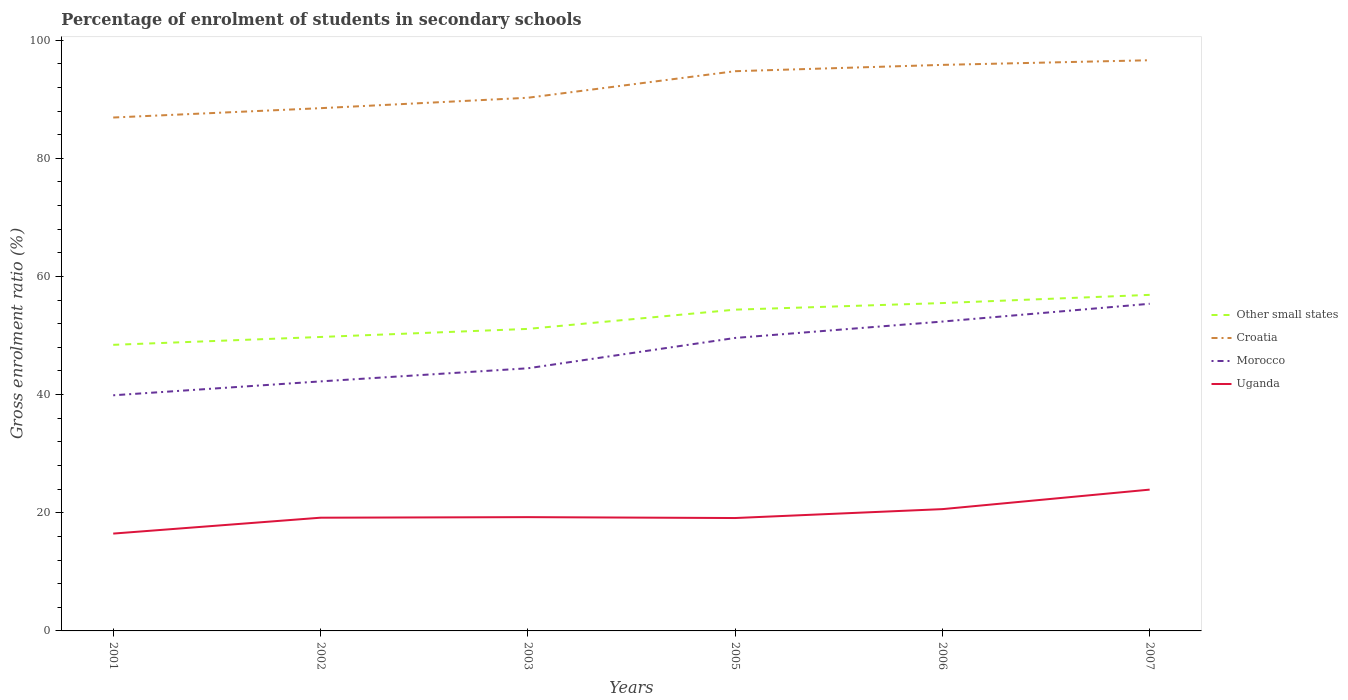How many different coloured lines are there?
Offer a terse response. 4. Does the line corresponding to Croatia intersect with the line corresponding to Uganda?
Offer a terse response. No. Is the number of lines equal to the number of legend labels?
Offer a terse response. Yes. Across all years, what is the maximum percentage of students enrolled in secondary schools in Croatia?
Make the answer very short. 86.91. In which year was the percentage of students enrolled in secondary schools in Uganda maximum?
Provide a short and direct response. 2001. What is the total percentage of students enrolled in secondary schools in Morocco in the graph?
Your answer should be compact. -9.71. What is the difference between the highest and the second highest percentage of students enrolled in secondary schools in Croatia?
Make the answer very short. 9.69. How many years are there in the graph?
Make the answer very short. 6. Does the graph contain any zero values?
Offer a terse response. No. Does the graph contain grids?
Your answer should be compact. No. Where does the legend appear in the graph?
Ensure brevity in your answer.  Center right. How many legend labels are there?
Provide a succinct answer. 4. How are the legend labels stacked?
Your answer should be compact. Vertical. What is the title of the graph?
Your answer should be very brief. Percentage of enrolment of students in secondary schools. Does "Guyana" appear as one of the legend labels in the graph?
Offer a terse response. No. What is the label or title of the X-axis?
Offer a very short reply. Years. What is the Gross enrolment ratio (%) in Other small states in 2001?
Offer a very short reply. 48.43. What is the Gross enrolment ratio (%) of Croatia in 2001?
Your response must be concise. 86.91. What is the Gross enrolment ratio (%) of Morocco in 2001?
Your answer should be compact. 39.89. What is the Gross enrolment ratio (%) in Uganda in 2001?
Make the answer very short. 16.48. What is the Gross enrolment ratio (%) of Other small states in 2002?
Make the answer very short. 49.76. What is the Gross enrolment ratio (%) in Croatia in 2002?
Your response must be concise. 88.49. What is the Gross enrolment ratio (%) in Morocco in 2002?
Provide a succinct answer. 42.24. What is the Gross enrolment ratio (%) of Uganda in 2002?
Offer a terse response. 19.16. What is the Gross enrolment ratio (%) of Other small states in 2003?
Provide a short and direct response. 51.12. What is the Gross enrolment ratio (%) of Croatia in 2003?
Ensure brevity in your answer.  90.25. What is the Gross enrolment ratio (%) in Morocco in 2003?
Your answer should be compact. 44.46. What is the Gross enrolment ratio (%) of Uganda in 2003?
Provide a succinct answer. 19.26. What is the Gross enrolment ratio (%) in Other small states in 2005?
Keep it short and to the point. 54.38. What is the Gross enrolment ratio (%) in Croatia in 2005?
Make the answer very short. 94.75. What is the Gross enrolment ratio (%) in Morocco in 2005?
Ensure brevity in your answer.  49.59. What is the Gross enrolment ratio (%) in Uganda in 2005?
Give a very brief answer. 19.11. What is the Gross enrolment ratio (%) in Other small states in 2006?
Your answer should be compact. 55.5. What is the Gross enrolment ratio (%) in Croatia in 2006?
Give a very brief answer. 95.81. What is the Gross enrolment ratio (%) in Morocco in 2006?
Provide a short and direct response. 52.37. What is the Gross enrolment ratio (%) in Uganda in 2006?
Give a very brief answer. 20.62. What is the Gross enrolment ratio (%) in Other small states in 2007?
Provide a short and direct response. 56.89. What is the Gross enrolment ratio (%) of Croatia in 2007?
Give a very brief answer. 96.6. What is the Gross enrolment ratio (%) of Morocco in 2007?
Your response must be concise. 55.38. What is the Gross enrolment ratio (%) in Uganda in 2007?
Ensure brevity in your answer.  23.92. Across all years, what is the maximum Gross enrolment ratio (%) of Other small states?
Your answer should be compact. 56.89. Across all years, what is the maximum Gross enrolment ratio (%) of Croatia?
Ensure brevity in your answer.  96.6. Across all years, what is the maximum Gross enrolment ratio (%) of Morocco?
Your answer should be very brief. 55.38. Across all years, what is the maximum Gross enrolment ratio (%) of Uganda?
Your response must be concise. 23.92. Across all years, what is the minimum Gross enrolment ratio (%) of Other small states?
Provide a short and direct response. 48.43. Across all years, what is the minimum Gross enrolment ratio (%) of Croatia?
Your answer should be compact. 86.91. Across all years, what is the minimum Gross enrolment ratio (%) in Morocco?
Give a very brief answer. 39.89. Across all years, what is the minimum Gross enrolment ratio (%) in Uganda?
Offer a terse response. 16.48. What is the total Gross enrolment ratio (%) in Other small states in the graph?
Offer a very short reply. 316.07. What is the total Gross enrolment ratio (%) of Croatia in the graph?
Offer a very short reply. 552.8. What is the total Gross enrolment ratio (%) in Morocco in the graph?
Offer a very short reply. 283.91. What is the total Gross enrolment ratio (%) in Uganda in the graph?
Make the answer very short. 118.54. What is the difference between the Gross enrolment ratio (%) of Other small states in 2001 and that in 2002?
Your answer should be very brief. -1.33. What is the difference between the Gross enrolment ratio (%) of Croatia in 2001 and that in 2002?
Provide a short and direct response. -1.58. What is the difference between the Gross enrolment ratio (%) of Morocco in 2001 and that in 2002?
Make the answer very short. -2.35. What is the difference between the Gross enrolment ratio (%) of Uganda in 2001 and that in 2002?
Keep it short and to the point. -2.69. What is the difference between the Gross enrolment ratio (%) in Other small states in 2001 and that in 2003?
Give a very brief answer. -2.7. What is the difference between the Gross enrolment ratio (%) in Croatia in 2001 and that in 2003?
Provide a succinct answer. -3.34. What is the difference between the Gross enrolment ratio (%) in Morocco in 2001 and that in 2003?
Your answer should be compact. -4.57. What is the difference between the Gross enrolment ratio (%) in Uganda in 2001 and that in 2003?
Provide a short and direct response. -2.78. What is the difference between the Gross enrolment ratio (%) in Other small states in 2001 and that in 2005?
Make the answer very short. -5.95. What is the difference between the Gross enrolment ratio (%) of Croatia in 2001 and that in 2005?
Ensure brevity in your answer.  -7.84. What is the difference between the Gross enrolment ratio (%) of Morocco in 2001 and that in 2005?
Provide a succinct answer. -9.71. What is the difference between the Gross enrolment ratio (%) of Uganda in 2001 and that in 2005?
Keep it short and to the point. -2.63. What is the difference between the Gross enrolment ratio (%) in Other small states in 2001 and that in 2006?
Offer a very short reply. -7.07. What is the difference between the Gross enrolment ratio (%) of Croatia in 2001 and that in 2006?
Your answer should be very brief. -8.91. What is the difference between the Gross enrolment ratio (%) in Morocco in 2001 and that in 2006?
Ensure brevity in your answer.  -12.48. What is the difference between the Gross enrolment ratio (%) of Uganda in 2001 and that in 2006?
Provide a short and direct response. -4.14. What is the difference between the Gross enrolment ratio (%) of Other small states in 2001 and that in 2007?
Make the answer very short. -8.46. What is the difference between the Gross enrolment ratio (%) of Croatia in 2001 and that in 2007?
Offer a very short reply. -9.69. What is the difference between the Gross enrolment ratio (%) in Morocco in 2001 and that in 2007?
Provide a succinct answer. -15.49. What is the difference between the Gross enrolment ratio (%) in Uganda in 2001 and that in 2007?
Your answer should be compact. -7.44. What is the difference between the Gross enrolment ratio (%) in Other small states in 2002 and that in 2003?
Your answer should be very brief. -1.37. What is the difference between the Gross enrolment ratio (%) of Croatia in 2002 and that in 2003?
Your answer should be very brief. -1.76. What is the difference between the Gross enrolment ratio (%) in Morocco in 2002 and that in 2003?
Keep it short and to the point. -2.22. What is the difference between the Gross enrolment ratio (%) in Uganda in 2002 and that in 2003?
Offer a very short reply. -0.09. What is the difference between the Gross enrolment ratio (%) of Other small states in 2002 and that in 2005?
Keep it short and to the point. -4.62. What is the difference between the Gross enrolment ratio (%) in Croatia in 2002 and that in 2005?
Offer a very short reply. -6.26. What is the difference between the Gross enrolment ratio (%) in Morocco in 2002 and that in 2005?
Provide a succinct answer. -7.35. What is the difference between the Gross enrolment ratio (%) in Uganda in 2002 and that in 2005?
Make the answer very short. 0.06. What is the difference between the Gross enrolment ratio (%) in Other small states in 2002 and that in 2006?
Ensure brevity in your answer.  -5.74. What is the difference between the Gross enrolment ratio (%) of Croatia in 2002 and that in 2006?
Keep it short and to the point. -7.33. What is the difference between the Gross enrolment ratio (%) in Morocco in 2002 and that in 2006?
Your answer should be very brief. -10.13. What is the difference between the Gross enrolment ratio (%) of Uganda in 2002 and that in 2006?
Make the answer very short. -1.45. What is the difference between the Gross enrolment ratio (%) of Other small states in 2002 and that in 2007?
Provide a succinct answer. -7.13. What is the difference between the Gross enrolment ratio (%) in Croatia in 2002 and that in 2007?
Provide a short and direct response. -8.11. What is the difference between the Gross enrolment ratio (%) in Morocco in 2002 and that in 2007?
Your answer should be compact. -13.14. What is the difference between the Gross enrolment ratio (%) in Uganda in 2002 and that in 2007?
Offer a very short reply. -4.75. What is the difference between the Gross enrolment ratio (%) in Other small states in 2003 and that in 2005?
Your answer should be compact. -3.26. What is the difference between the Gross enrolment ratio (%) of Croatia in 2003 and that in 2005?
Your answer should be very brief. -4.5. What is the difference between the Gross enrolment ratio (%) in Morocco in 2003 and that in 2005?
Provide a succinct answer. -5.13. What is the difference between the Gross enrolment ratio (%) of Uganda in 2003 and that in 2005?
Make the answer very short. 0.15. What is the difference between the Gross enrolment ratio (%) in Other small states in 2003 and that in 2006?
Your answer should be very brief. -4.38. What is the difference between the Gross enrolment ratio (%) in Croatia in 2003 and that in 2006?
Offer a terse response. -5.56. What is the difference between the Gross enrolment ratio (%) in Morocco in 2003 and that in 2006?
Offer a terse response. -7.91. What is the difference between the Gross enrolment ratio (%) in Uganda in 2003 and that in 2006?
Offer a very short reply. -1.36. What is the difference between the Gross enrolment ratio (%) of Other small states in 2003 and that in 2007?
Give a very brief answer. -5.76. What is the difference between the Gross enrolment ratio (%) of Croatia in 2003 and that in 2007?
Offer a very short reply. -6.35. What is the difference between the Gross enrolment ratio (%) in Morocco in 2003 and that in 2007?
Provide a short and direct response. -10.92. What is the difference between the Gross enrolment ratio (%) in Uganda in 2003 and that in 2007?
Make the answer very short. -4.66. What is the difference between the Gross enrolment ratio (%) in Other small states in 2005 and that in 2006?
Offer a very short reply. -1.12. What is the difference between the Gross enrolment ratio (%) in Croatia in 2005 and that in 2006?
Make the answer very short. -1.07. What is the difference between the Gross enrolment ratio (%) in Morocco in 2005 and that in 2006?
Provide a short and direct response. -2.77. What is the difference between the Gross enrolment ratio (%) of Uganda in 2005 and that in 2006?
Your answer should be compact. -1.51. What is the difference between the Gross enrolment ratio (%) of Other small states in 2005 and that in 2007?
Provide a succinct answer. -2.51. What is the difference between the Gross enrolment ratio (%) of Croatia in 2005 and that in 2007?
Offer a very short reply. -1.85. What is the difference between the Gross enrolment ratio (%) in Morocco in 2005 and that in 2007?
Give a very brief answer. -5.78. What is the difference between the Gross enrolment ratio (%) in Uganda in 2005 and that in 2007?
Keep it short and to the point. -4.81. What is the difference between the Gross enrolment ratio (%) of Other small states in 2006 and that in 2007?
Offer a terse response. -1.39. What is the difference between the Gross enrolment ratio (%) of Croatia in 2006 and that in 2007?
Offer a very short reply. -0.79. What is the difference between the Gross enrolment ratio (%) in Morocco in 2006 and that in 2007?
Make the answer very short. -3.01. What is the difference between the Gross enrolment ratio (%) in Uganda in 2006 and that in 2007?
Offer a very short reply. -3.3. What is the difference between the Gross enrolment ratio (%) in Other small states in 2001 and the Gross enrolment ratio (%) in Croatia in 2002?
Your answer should be very brief. -40.06. What is the difference between the Gross enrolment ratio (%) in Other small states in 2001 and the Gross enrolment ratio (%) in Morocco in 2002?
Keep it short and to the point. 6.19. What is the difference between the Gross enrolment ratio (%) in Other small states in 2001 and the Gross enrolment ratio (%) in Uganda in 2002?
Offer a very short reply. 29.26. What is the difference between the Gross enrolment ratio (%) of Croatia in 2001 and the Gross enrolment ratio (%) of Morocco in 2002?
Keep it short and to the point. 44.67. What is the difference between the Gross enrolment ratio (%) in Croatia in 2001 and the Gross enrolment ratio (%) in Uganda in 2002?
Keep it short and to the point. 67.74. What is the difference between the Gross enrolment ratio (%) of Morocco in 2001 and the Gross enrolment ratio (%) of Uganda in 2002?
Offer a terse response. 20.72. What is the difference between the Gross enrolment ratio (%) of Other small states in 2001 and the Gross enrolment ratio (%) of Croatia in 2003?
Give a very brief answer. -41.82. What is the difference between the Gross enrolment ratio (%) of Other small states in 2001 and the Gross enrolment ratio (%) of Morocco in 2003?
Ensure brevity in your answer.  3.97. What is the difference between the Gross enrolment ratio (%) of Other small states in 2001 and the Gross enrolment ratio (%) of Uganda in 2003?
Ensure brevity in your answer.  29.17. What is the difference between the Gross enrolment ratio (%) of Croatia in 2001 and the Gross enrolment ratio (%) of Morocco in 2003?
Your response must be concise. 42.45. What is the difference between the Gross enrolment ratio (%) in Croatia in 2001 and the Gross enrolment ratio (%) in Uganda in 2003?
Offer a terse response. 67.65. What is the difference between the Gross enrolment ratio (%) in Morocco in 2001 and the Gross enrolment ratio (%) in Uganda in 2003?
Your response must be concise. 20.63. What is the difference between the Gross enrolment ratio (%) in Other small states in 2001 and the Gross enrolment ratio (%) in Croatia in 2005?
Make the answer very short. -46.32. What is the difference between the Gross enrolment ratio (%) in Other small states in 2001 and the Gross enrolment ratio (%) in Morocco in 2005?
Offer a terse response. -1.16. What is the difference between the Gross enrolment ratio (%) of Other small states in 2001 and the Gross enrolment ratio (%) of Uganda in 2005?
Your answer should be compact. 29.32. What is the difference between the Gross enrolment ratio (%) in Croatia in 2001 and the Gross enrolment ratio (%) in Morocco in 2005?
Keep it short and to the point. 37.31. What is the difference between the Gross enrolment ratio (%) of Croatia in 2001 and the Gross enrolment ratio (%) of Uganda in 2005?
Offer a terse response. 67.8. What is the difference between the Gross enrolment ratio (%) of Morocco in 2001 and the Gross enrolment ratio (%) of Uganda in 2005?
Your answer should be compact. 20.78. What is the difference between the Gross enrolment ratio (%) in Other small states in 2001 and the Gross enrolment ratio (%) in Croatia in 2006?
Ensure brevity in your answer.  -47.39. What is the difference between the Gross enrolment ratio (%) of Other small states in 2001 and the Gross enrolment ratio (%) of Morocco in 2006?
Offer a terse response. -3.94. What is the difference between the Gross enrolment ratio (%) in Other small states in 2001 and the Gross enrolment ratio (%) in Uganda in 2006?
Make the answer very short. 27.81. What is the difference between the Gross enrolment ratio (%) in Croatia in 2001 and the Gross enrolment ratio (%) in Morocco in 2006?
Make the answer very short. 34.54. What is the difference between the Gross enrolment ratio (%) in Croatia in 2001 and the Gross enrolment ratio (%) in Uganda in 2006?
Ensure brevity in your answer.  66.29. What is the difference between the Gross enrolment ratio (%) of Morocco in 2001 and the Gross enrolment ratio (%) of Uganda in 2006?
Offer a terse response. 19.27. What is the difference between the Gross enrolment ratio (%) of Other small states in 2001 and the Gross enrolment ratio (%) of Croatia in 2007?
Offer a terse response. -48.17. What is the difference between the Gross enrolment ratio (%) in Other small states in 2001 and the Gross enrolment ratio (%) in Morocco in 2007?
Make the answer very short. -6.95. What is the difference between the Gross enrolment ratio (%) in Other small states in 2001 and the Gross enrolment ratio (%) in Uganda in 2007?
Ensure brevity in your answer.  24.51. What is the difference between the Gross enrolment ratio (%) in Croatia in 2001 and the Gross enrolment ratio (%) in Morocco in 2007?
Make the answer very short. 31.53. What is the difference between the Gross enrolment ratio (%) of Croatia in 2001 and the Gross enrolment ratio (%) of Uganda in 2007?
Give a very brief answer. 62.99. What is the difference between the Gross enrolment ratio (%) of Morocco in 2001 and the Gross enrolment ratio (%) of Uganda in 2007?
Offer a terse response. 15.97. What is the difference between the Gross enrolment ratio (%) in Other small states in 2002 and the Gross enrolment ratio (%) in Croatia in 2003?
Ensure brevity in your answer.  -40.49. What is the difference between the Gross enrolment ratio (%) in Other small states in 2002 and the Gross enrolment ratio (%) in Morocco in 2003?
Your response must be concise. 5.3. What is the difference between the Gross enrolment ratio (%) in Other small states in 2002 and the Gross enrolment ratio (%) in Uganda in 2003?
Ensure brevity in your answer.  30.5. What is the difference between the Gross enrolment ratio (%) in Croatia in 2002 and the Gross enrolment ratio (%) in Morocco in 2003?
Your answer should be compact. 44.03. What is the difference between the Gross enrolment ratio (%) in Croatia in 2002 and the Gross enrolment ratio (%) in Uganda in 2003?
Offer a very short reply. 69.23. What is the difference between the Gross enrolment ratio (%) of Morocco in 2002 and the Gross enrolment ratio (%) of Uganda in 2003?
Offer a very short reply. 22.98. What is the difference between the Gross enrolment ratio (%) of Other small states in 2002 and the Gross enrolment ratio (%) of Croatia in 2005?
Your answer should be very brief. -44.99. What is the difference between the Gross enrolment ratio (%) in Other small states in 2002 and the Gross enrolment ratio (%) in Morocco in 2005?
Your answer should be very brief. 0.17. What is the difference between the Gross enrolment ratio (%) in Other small states in 2002 and the Gross enrolment ratio (%) in Uganda in 2005?
Keep it short and to the point. 30.65. What is the difference between the Gross enrolment ratio (%) of Croatia in 2002 and the Gross enrolment ratio (%) of Morocco in 2005?
Make the answer very short. 38.9. What is the difference between the Gross enrolment ratio (%) of Croatia in 2002 and the Gross enrolment ratio (%) of Uganda in 2005?
Offer a very short reply. 69.38. What is the difference between the Gross enrolment ratio (%) in Morocco in 2002 and the Gross enrolment ratio (%) in Uganda in 2005?
Offer a terse response. 23.13. What is the difference between the Gross enrolment ratio (%) in Other small states in 2002 and the Gross enrolment ratio (%) in Croatia in 2006?
Provide a short and direct response. -46.06. What is the difference between the Gross enrolment ratio (%) in Other small states in 2002 and the Gross enrolment ratio (%) in Morocco in 2006?
Your answer should be compact. -2.61. What is the difference between the Gross enrolment ratio (%) in Other small states in 2002 and the Gross enrolment ratio (%) in Uganda in 2006?
Offer a terse response. 29.14. What is the difference between the Gross enrolment ratio (%) in Croatia in 2002 and the Gross enrolment ratio (%) in Morocco in 2006?
Keep it short and to the point. 36.12. What is the difference between the Gross enrolment ratio (%) of Croatia in 2002 and the Gross enrolment ratio (%) of Uganda in 2006?
Offer a very short reply. 67.87. What is the difference between the Gross enrolment ratio (%) in Morocco in 2002 and the Gross enrolment ratio (%) in Uganda in 2006?
Provide a succinct answer. 21.62. What is the difference between the Gross enrolment ratio (%) of Other small states in 2002 and the Gross enrolment ratio (%) of Croatia in 2007?
Offer a very short reply. -46.84. What is the difference between the Gross enrolment ratio (%) of Other small states in 2002 and the Gross enrolment ratio (%) of Morocco in 2007?
Give a very brief answer. -5.62. What is the difference between the Gross enrolment ratio (%) of Other small states in 2002 and the Gross enrolment ratio (%) of Uganda in 2007?
Your response must be concise. 25.84. What is the difference between the Gross enrolment ratio (%) of Croatia in 2002 and the Gross enrolment ratio (%) of Morocco in 2007?
Provide a succinct answer. 33.11. What is the difference between the Gross enrolment ratio (%) in Croatia in 2002 and the Gross enrolment ratio (%) in Uganda in 2007?
Offer a very short reply. 64.57. What is the difference between the Gross enrolment ratio (%) of Morocco in 2002 and the Gross enrolment ratio (%) of Uganda in 2007?
Provide a succinct answer. 18.32. What is the difference between the Gross enrolment ratio (%) of Other small states in 2003 and the Gross enrolment ratio (%) of Croatia in 2005?
Provide a short and direct response. -43.62. What is the difference between the Gross enrolment ratio (%) in Other small states in 2003 and the Gross enrolment ratio (%) in Morocco in 2005?
Your answer should be very brief. 1.53. What is the difference between the Gross enrolment ratio (%) of Other small states in 2003 and the Gross enrolment ratio (%) of Uganda in 2005?
Provide a short and direct response. 32.01. What is the difference between the Gross enrolment ratio (%) in Croatia in 2003 and the Gross enrolment ratio (%) in Morocco in 2005?
Your answer should be compact. 40.66. What is the difference between the Gross enrolment ratio (%) in Croatia in 2003 and the Gross enrolment ratio (%) in Uganda in 2005?
Offer a very short reply. 71.14. What is the difference between the Gross enrolment ratio (%) of Morocco in 2003 and the Gross enrolment ratio (%) of Uganda in 2005?
Your answer should be compact. 25.35. What is the difference between the Gross enrolment ratio (%) in Other small states in 2003 and the Gross enrolment ratio (%) in Croatia in 2006?
Provide a succinct answer. -44.69. What is the difference between the Gross enrolment ratio (%) in Other small states in 2003 and the Gross enrolment ratio (%) in Morocco in 2006?
Provide a short and direct response. -1.24. What is the difference between the Gross enrolment ratio (%) of Other small states in 2003 and the Gross enrolment ratio (%) of Uganda in 2006?
Provide a succinct answer. 30.51. What is the difference between the Gross enrolment ratio (%) of Croatia in 2003 and the Gross enrolment ratio (%) of Morocco in 2006?
Your response must be concise. 37.88. What is the difference between the Gross enrolment ratio (%) in Croatia in 2003 and the Gross enrolment ratio (%) in Uganda in 2006?
Provide a short and direct response. 69.63. What is the difference between the Gross enrolment ratio (%) in Morocco in 2003 and the Gross enrolment ratio (%) in Uganda in 2006?
Offer a very short reply. 23.84. What is the difference between the Gross enrolment ratio (%) in Other small states in 2003 and the Gross enrolment ratio (%) in Croatia in 2007?
Offer a terse response. -45.48. What is the difference between the Gross enrolment ratio (%) in Other small states in 2003 and the Gross enrolment ratio (%) in Morocco in 2007?
Your answer should be very brief. -4.25. What is the difference between the Gross enrolment ratio (%) of Other small states in 2003 and the Gross enrolment ratio (%) of Uganda in 2007?
Provide a short and direct response. 27.2. What is the difference between the Gross enrolment ratio (%) in Croatia in 2003 and the Gross enrolment ratio (%) in Morocco in 2007?
Your response must be concise. 34.87. What is the difference between the Gross enrolment ratio (%) in Croatia in 2003 and the Gross enrolment ratio (%) in Uganda in 2007?
Your answer should be very brief. 66.33. What is the difference between the Gross enrolment ratio (%) in Morocco in 2003 and the Gross enrolment ratio (%) in Uganda in 2007?
Provide a short and direct response. 20.54. What is the difference between the Gross enrolment ratio (%) of Other small states in 2005 and the Gross enrolment ratio (%) of Croatia in 2006?
Give a very brief answer. -41.43. What is the difference between the Gross enrolment ratio (%) of Other small states in 2005 and the Gross enrolment ratio (%) of Morocco in 2006?
Your answer should be very brief. 2.02. What is the difference between the Gross enrolment ratio (%) of Other small states in 2005 and the Gross enrolment ratio (%) of Uganda in 2006?
Provide a succinct answer. 33.76. What is the difference between the Gross enrolment ratio (%) of Croatia in 2005 and the Gross enrolment ratio (%) of Morocco in 2006?
Keep it short and to the point. 42.38. What is the difference between the Gross enrolment ratio (%) in Croatia in 2005 and the Gross enrolment ratio (%) in Uganda in 2006?
Ensure brevity in your answer.  74.13. What is the difference between the Gross enrolment ratio (%) in Morocco in 2005 and the Gross enrolment ratio (%) in Uganda in 2006?
Your answer should be very brief. 28.98. What is the difference between the Gross enrolment ratio (%) in Other small states in 2005 and the Gross enrolment ratio (%) in Croatia in 2007?
Your response must be concise. -42.22. What is the difference between the Gross enrolment ratio (%) of Other small states in 2005 and the Gross enrolment ratio (%) of Morocco in 2007?
Keep it short and to the point. -0.99. What is the difference between the Gross enrolment ratio (%) in Other small states in 2005 and the Gross enrolment ratio (%) in Uganda in 2007?
Your answer should be compact. 30.46. What is the difference between the Gross enrolment ratio (%) in Croatia in 2005 and the Gross enrolment ratio (%) in Morocco in 2007?
Give a very brief answer. 39.37. What is the difference between the Gross enrolment ratio (%) of Croatia in 2005 and the Gross enrolment ratio (%) of Uganda in 2007?
Your answer should be very brief. 70.83. What is the difference between the Gross enrolment ratio (%) of Morocco in 2005 and the Gross enrolment ratio (%) of Uganda in 2007?
Your answer should be very brief. 25.67. What is the difference between the Gross enrolment ratio (%) of Other small states in 2006 and the Gross enrolment ratio (%) of Croatia in 2007?
Make the answer very short. -41.1. What is the difference between the Gross enrolment ratio (%) in Other small states in 2006 and the Gross enrolment ratio (%) in Morocco in 2007?
Make the answer very short. 0.12. What is the difference between the Gross enrolment ratio (%) in Other small states in 2006 and the Gross enrolment ratio (%) in Uganda in 2007?
Your response must be concise. 31.58. What is the difference between the Gross enrolment ratio (%) of Croatia in 2006 and the Gross enrolment ratio (%) of Morocco in 2007?
Keep it short and to the point. 40.44. What is the difference between the Gross enrolment ratio (%) in Croatia in 2006 and the Gross enrolment ratio (%) in Uganda in 2007?
Keep it short and to the point. 71.9. What is the difference between the Gross enrolment ratio (%) in Morocco in 2006 and the Gross enrolment ratio (%) in Uganda in 2007?
Keep it short and to the point. 28.45. What is the average Gross enrolment ratio (%) of Other small states per year?
Keep it short and to the point. 52.68. What is the average Gross enrolment ratio (%) in Croatia per year?
Keep it short and to the point. 92.13. What is the average Gross enrolment ratio (%) in Morocco per year?
Give a very brief answer. 47.32. What is the average Gross enrolment ratio (%) of Uganda per year?
Offer a very short reply. 19.76. In the year 2001, what is the difference between the Gross enrolment ratio (%) of Other small states and Gross enrolment ratio (%) of Croatia?
Make the answer very short. -38.48. In the year 2001, what is the difference between the Gross enrolment ratio (%) of Other small states and Gross enrolment ratio (%) of Morocco?
Ensure brevity in your answer.  8.54. In the year 2001, what is the difference between the Gross enrolment ratio (%) in Other small states and Gross enrolment ratio (%) in Uganda?
Provide a short and direct response. 31.95. In the year 2001, what is the difference between the Gross enrolment ratio (%) in Croatia and Gross enrolment ratio (%) in Morocco?
Your answer should be very brief. 47.02. In the year 2001, what is the difference between the Gross enrolment ratio (%) of Croatia and Gross enrolment ratio (%) of Uganda?
Provide a short and direct response. 70.43. In the year 2001, what is the difference between the Gross enrolment ratio (%) of Morocco and Gross enrolment ratio (%) of Uganda?
Make the answer very short. 23.41. In the year 2002, what is the difference between the Gross enrolment ratio (%) of Other small states and Gross enrolment ratio (%) of Croatia?
Provide a short and direct response. -38.73. In the year 2002, what is the difference between the Gross enrolment ratio (%) in Other small states and Gross enrolment ratio (%) in Morocco?
Provide a succinct answer. 7.52. In the year 2002, what is the difference between the Gross enrolment ratio (%) of Other small states and Gross enrolment ratio (%) of Uganda?
Provide a succinct answer. 30.59. In the year 2002, what is the difference between the Gross enrolment ratio (%) in Croatia and Gross enrolment ratio (%) in Morocco?
Provide a short and direct response. 46.25. In the year 2002, what is the difference between the Gross enrolment ratio (%) in Croatia and Gross enrolment ratio (%) in Uganda?
Your answer should be very brief. 69.32. In the year 2002, what is the difference between the Gross enrolment ratio (%) in Morocco and Gross enrolment ratio (%) in Uganda?
Offer a very short reply. 23.07. In the year 2003, what is the difference between the Gross enrolment ratio (%) of Other small states and Gross enrolment ratio (%) of Croatia?
Offer a terse response. -39.13. In the year 2003, what is the difference between the Gross enrolment ratio (%) in Other small states and Gross enrolment ratio (%) in Morocco?
Your answer should be compact. 6.67. In the year 2003, what is the difference between the Gross enrolment ratio (%) in Other small states and Gross enrolment ratio (%) in Uganda?
Provide a succinct answer. 31.86. In the year 2003, what is the difference between the Gross enrolment ratio (%) of Croatia and Gross enrolment ratio (%) of Morocco?
Offer a terse response. 45.79. In the year 2003, what is the difference between the Gross enrolment ratio (%) of Croatia and Gross enrolment ratio (%) of Uganda?
Your response must be concise. 70.99. In the year 2003, what is the difference between the Gross enrolment ratio (%) of Morocco and Gross enrolment ratio (%) of Uganda?
Offer a terse response. 25.2. In the year 2005, what is the difference between the Gross enrolment ratio (%) in Other small states and Gross enrolment ratio (%) in Croatia?
Offer a terse response. -40.36. In the year 2005, what is the difference between the Gross enrolment ratio (%) in Other small states and Gross enrolment ratio (%) in Morocco?
Offer a terse response. 4.79. In the year 2005, what is the difference between the Gross enrolment ratio (%) of Other small states and Gross enrolment ratio (%) of Uganda?
Offer a terse response. 35.27. In the year 2005, what is the difference between the Gross enrolment ratio (%) of Croatia and Gross enrolment ratio (%) of Morocco?
Your answer should be very brief. 45.15. In the year 2005, what is the difference between the Gross enrolment ratio (%) in Croatia and Gross enrolment ratio (%) in Uganda?
Your answer should be very brief. 75.64. In the year 2005, what is the difference between the Gross enrolment ratio (%) in Morocco and Gross enrolment ratio (%) in Uganda?
Give a very brief answer. 30.48. In the year 2006, what is the difference between the Gross enrolment ratio (%) in Other small states and Gross enrolment ratio (%) in Croatia?
Your answer should be compact. -40.32. In the year 2006, what is the difference between the Gross enrolment ratio (%) of Other small states and Gross enrolment ratio (%) of Morocco?
Ensure brevity in your answer.  3.13. In the year 2006, what is the difference between the Gross enrolment ratio (%) of Other small states and Gross enrolment ratio (%) of Uganda?
Keep it short and to the point. 34.88. In the year 2006, what is the difference between the Gross enrolment ratio (%) of Croatia and Gross enrolment ratio (%) of Morocco?
Offer a very short reply. 43.45. In the year 2006, what is the difference between the Gross enrolment ratio (%) of Croatia and Gross enrolment ratio (%) of Uganda?
Provide a short and direct response. 75.2. In the year 2006, what is the difference between the Gross enrolment ratio (%) of Morocco and Gross enrolment ratio (%) of Uganda?
Keep it short and to the point. 31.75. In the year 2007, what is the difference between the Gross enrolment ratio (%) in Other small states and Gross enrolment ratio (%) in Croatia?
Your answer should be compact. -39.71. In the year 2007, what is the difference between the Gross enrolment ratio (%) of Other small states and Gross enrolment ratio (%) of Morocco?
Your answer should be compact. 1.51. In the year 2007, what is the difference between the Gross enrolment ratio (%) of Other small states and Gross enrolment ratio (%) of Uganda?
Give a very brief answer. 32.97. In the year 2007, what is the difference between the Gross enrolment ratio (%) in Croatia and Gross enrolment ratio (%) in Morocco?
Offer a very short reply. 41.22. In the year 2007, what is the difference between the Gross enrolment ratio (%) in Croatia and Gross enrolment ratio (%) in Uganda?
Your answer should be compact. 72.68. In the year 2007, what is the difference between the Gross enrolment ratio (%) of Morocco and Gross enrolment ratio (%) of Uganda?
Your answer should be compact. 31.46. What is the ratio of the Gross enrolment ratio (%) of Other small states in 2001 to that in 2002?
Ensure brevity in your answer.  0.97. What is the ratio of the Gross enrolment ratio (%) of Croatia in 2001 to that in 2002?
Your response must be concise. 0.98. What is the ratio of the Gross enrolment ratio (%) of Morocco in 2001 to that in 2002?
Provide a succinct answer. 0.94. What is the ratio of the Gross enrolment ratio (%) in Uganda in 2001 to that in 2002?
Your response must be concise. 0.86. What is the ratio of the Gross enrolment ratio (%) of Other small states in 2001 to that in 2003?
Make the answer very short. 0.95. What is the ratio of the Gross enrolment ratio (%) in Croatia in 2001 to that in 2003?
Your answer should be compact. 0.96. What is the ratio of the Gross enrolment ratio (%) in Morocco in 2001 to that in 2003?
Your answer should be very brief. 0.9. What is the ratio of the Gross enrolment ratio (%) in Uganda in 2001 to that in 2003?
Your answer should be very brief. 0.86. What is the ratio of the Gross enrolment ratio (%) in Other small states in 2001 to that in 2005?
Your answer should be compact. 0.89. What is the ratio of the Gross enrolment ratio (%) of Croatia in 2001 to that in 2005?
Offer a very short reply. 0.92. What is the ratio of the Gross enrolment ratio (%) in Morocco in 2001 to that in 2005?
Make the answer very short. 0.8. What is the ratio of the Gross enrolment ratio (%) in Uganda in 2001 to that in 2005?
Offer a very short reply. 0.86. What is the ratio of the Gross enrolment ratio (%) in Other small states in 2001 to that in 2006?
Ensure brevity in your answer.  0.87. What is the ratio of the Gross enrolment ratio (%) of Croatia in 2001 to that in 2006?
Your answer should be very brief. 0.91. What is the ratio of the Gross enrolment ratio (%) of Morocco in 2001 to that in 2006?
Your answer should be compact. 0.76. What is the ratio of the Gross enrolment ratio (%) in Uganda in 2001 to that in 2006?
Ensure brevity in your answer.  0.8. What is the ratio of the Gross enrolment ratio (%) in Other small states in 2001 to that in 2007?
Keep it short and to the point. 0.85. What is the ratio of the Gross enrolment ratio (%) of Croatia in 2001 to that in 2007?
Offer a very short reply. 0.9. What is the ratio of the Gross enrolment ratio (%) of Morocco in 2001 to that in 2007?
Your response must be concise. 0.72. What is the ratio of the Gross enrolment ratio (%) of Uganda in 2001 to that in 2007?
Ensure brevity in your answer.  0.69. What is the ratio of the Gross enrolment ratio (%) of Other small states in 2002 to that in 2003?
Your answer should be compact. 0.97. What is the ratio of the Gross enrolment ratio (%) of Croatia in 2002 to that in 2003?
Offer a terse response. 0.98. What is the ratio of the Gross enrolment ratio (%) in Morocco in 2002 to that in 2003?
Your answer should be compact. 0.95. What is the ratio of the Gross enrolment ratio (%) in Other small states in 2002 to that in 2005?
Keep it short and to the point. 0.92. What is the ratio of the Gross enrolment ratio (%) of Croatia in 2002 to that in 2005?
Your response must be concise. 0.93. What is the ratio of the Gross enrolment ratio (%) in Morocco in 2002 to that in 2005?
Give a very brief answer. 0.85. What is the ratio of the Gross enrolment ratio (%) of Uganda in 2002 to that in 2005?
Provide a short and direct response. 1. What is the ratio of the Gross enrolment ratio (%) of Other small states in 2002 to that in 2006?
Offer a very short reply. 0.9. What is the ratio of the Gross enrolment ratio (%) in Croatia in 2002 to that in 2006?
Provide a short and direct response. 0.92. What is the ratio of the Gross enrolment ratio (%) of Morocco in 2002 to that in 2006?
Your answer should be very brief. 0.81. What is the ratio of the Gross enrolment ratio (%) in Uganda in 2002 to that in 2006?
Provide a short and direct response. 0.93. What is the ratio of the Gross enrolment ratio (%) in Other small states in 2002 to that in 2007?
Your answer should be very brief. 0.87. What is the ratio of the Gross enrolment ratio (%) in Croatia in 2002 to that in 2007?
Give a very brief answer. 0.92. What is the ratio of the Gross enrolment ratio (%) in Morocco in 2002 to that in 2007?
Give a very brief answer. 0.76. What is the ratio of the Gross enrolment ratio (%) in Uganda in 2002 to that in 2007?
Your answer should be very brief. 0.8. What is the ratio of the Gross enrolment ratio (%) of Other small states in 2003 to that in 2005?
Offer a terse response. 0.94. What is the ratio of the Gross enrolment ratio (%) in Croatia in 2003 to that in 2005?
Provide a short and direct response. 0.95. What is the ratio of the Gross enrolment ratio (%) of Morocco in 2003 to that in 2005?
Ensure brevity in your answer.  0.9. What is the ratio of the Gross enrolment ratio (%) in Uganda in 2003 to that in 2005?
Your response must be concise. 1.01. What is the ratio of the Gross enrolment ratio (%) of Other small states in 2003 to that in 2006?
Offer a very short reply. 0.92. What is the ratio of the Gross enrolment ratio (%) in Croatia in 2003 to that in 2006?
Your response must be concise. 0.94. What is the ratio of the Gross enrolment ratio (%) of Morocco in 2003 to that in 2006?
Keep it short and to the point. 0.85. What is the ratio of the Gross enrolment ratio (%) in Uganda in 2003 to that in 2006?
Your response must be concise. 0.93. What is the ratio of the Gross enrolment ratio (%) in Other small states in 2003 to that in 2007?
Keep it short and to the point. 0.9. What is the ratio of the Gross enrolment ratio (%) of Croatia in 2003 to that in 2007?
Offer a very short reply. 0.93. What is the ratio of the Gross enrolment ratio (%) in Morocco in 2003 to that in 2007?
Your answer should be compact. 0.8. What is the ratio of the Gross enrolment ratio (%) of Uganda in 2003 to that in 2007?
Your response must be concise. 0.81. What is the ratio of the Gross enrolment ratio (%) in Other small states in 2005 to that in 2006?
Your answer should be very brief. 0.98. What is the ratio of the Gross enrolment ratio (%) of Morocco in 2005 to that in 2006?
Your response must be concise. 0.95. What is the ratio of the Gross enrolment ratio (%) in Uganda in 2005 to that in 2006?
Provide a short and direct response. 0.93. What is the ratio of the Gross enrolment ratio (%) of Other small states in 2005 to that in 2007?
Your answer should be very brief. 0.96. What is the ratio of the Gross enrolment ratio (%) in Croatia in 2005 to that in 2007?
Offer a very short reply. 0.98. What is the ratio of the Gross enrolment ratio (%) of Morocco in 2005 to that in 2007?
Your answer should be very brief. 0.9. What is the ratio of the Gross enrolment ratio (%) of Uganda in 2005 to that in 2007?
Your answer should be compact. 0.8. What is the ratio of the Gross enrolment ratio (%) in Other small states in 2006 to that in 2007?
Your response must be concise. 0.98. What is the ratio of the Gross enrolment ratio (%) of Morocco in 2006 to that in 2007?
Provide a succinct answer. 0.95. What is the ratio of the Gross enrolment ratio (%) of Uganda in 2006 to that in 2007?
Your answer should be very brief. 0.86. What is the difference between the highest and the second highest Gross enrolment ratio (%) of Other small states?
Your answer should be very brief. 1.39. What is the difference between the highest and the second highest Gross enrolment ratio (%) in Croatia?
Offer a terse response. 0.79. What is the difference between the highest and the second highest Gross enrolment ratio (%) of Morocco?
Keep it short and to the point. 3.01. What is the difference between the highest and the second highest Gross enrolment ratio (%) in Uganda?
Provide a succinct answer. 3.3. What is the difference between the highest and the lowest Gross enrolment ratio (%) of Other small states?
Ensure brevity in your answer.  8.46. What is the difference between the highest and the lowest Gross enrolment ratio (%) in Croatia?
Give a very brief answer. 9.69. What is the difference between the highest and the lowest Gross enrolment ratio (%) of Morocco?
Your answer should be compact. 15.49. What is the difference between the highest and the lowest Gross enrolment ratio (%) in Uganda?
Keep it short and to the point. 7.44. 